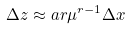<formula> <loc_0><loc_0><loc_500><loc_500>\Delta z \approx a r \mu ^ { r - 1 } \Delta x</formula> 